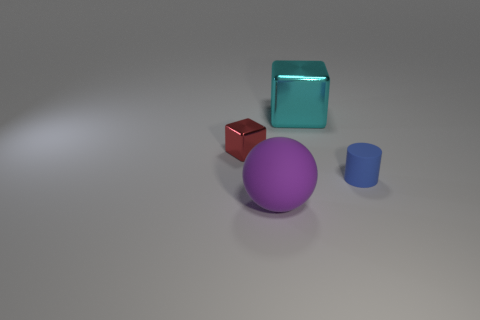There is another metal thing that is the same shape as the small red metallic thing; what is its color?
Keep it short and to the point. Cyan. What is the size of the object that is the same material as the small cylinder?
Make the answer very short. Large. There is another object that is the same shape as the cyan thing; what is its size?
Make the answer very short. Small. There is a red object; is its shape the same as the big thing behind the tiny blue cylinder?
Your answer should be compact. Yes. What is the material of the large sphere?
Your response must be concise. Rubber. There is a large cyan object that is made of the same material as the tiny red object; what is its shape?
Your answer should be very brief. Cube. There is a shiny block to the left of the big object that is behind the red block; what is its size?
Your answer should be very brief. Small. What is the color of the small object that is in front of the tiny shiny object?
Give a very brief answer. Blue. Are there any other small red metallic objects of the same shape as the small metal object?
Provide a short and direct response. No. Are there fewer small blocks in front of the purple rubber ball than tiny cubes on the left side of the tiny red metal object?
Give a very brief answer. No. 